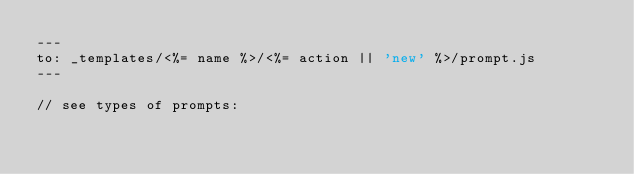Convert code to text. <code><loc_0><loc_0><loc_500><loc_500><_Perl_>---
to: _templates/<%= name %>/<%= action || 'new' %>/prompt.js
---

// see types of prompts:</code> 